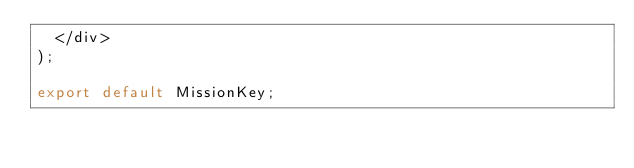<code> <loc_0><loc_0><loc_500><loc_500><_JavaScript_>  </div>
);

export default MissionKey;
</code> 